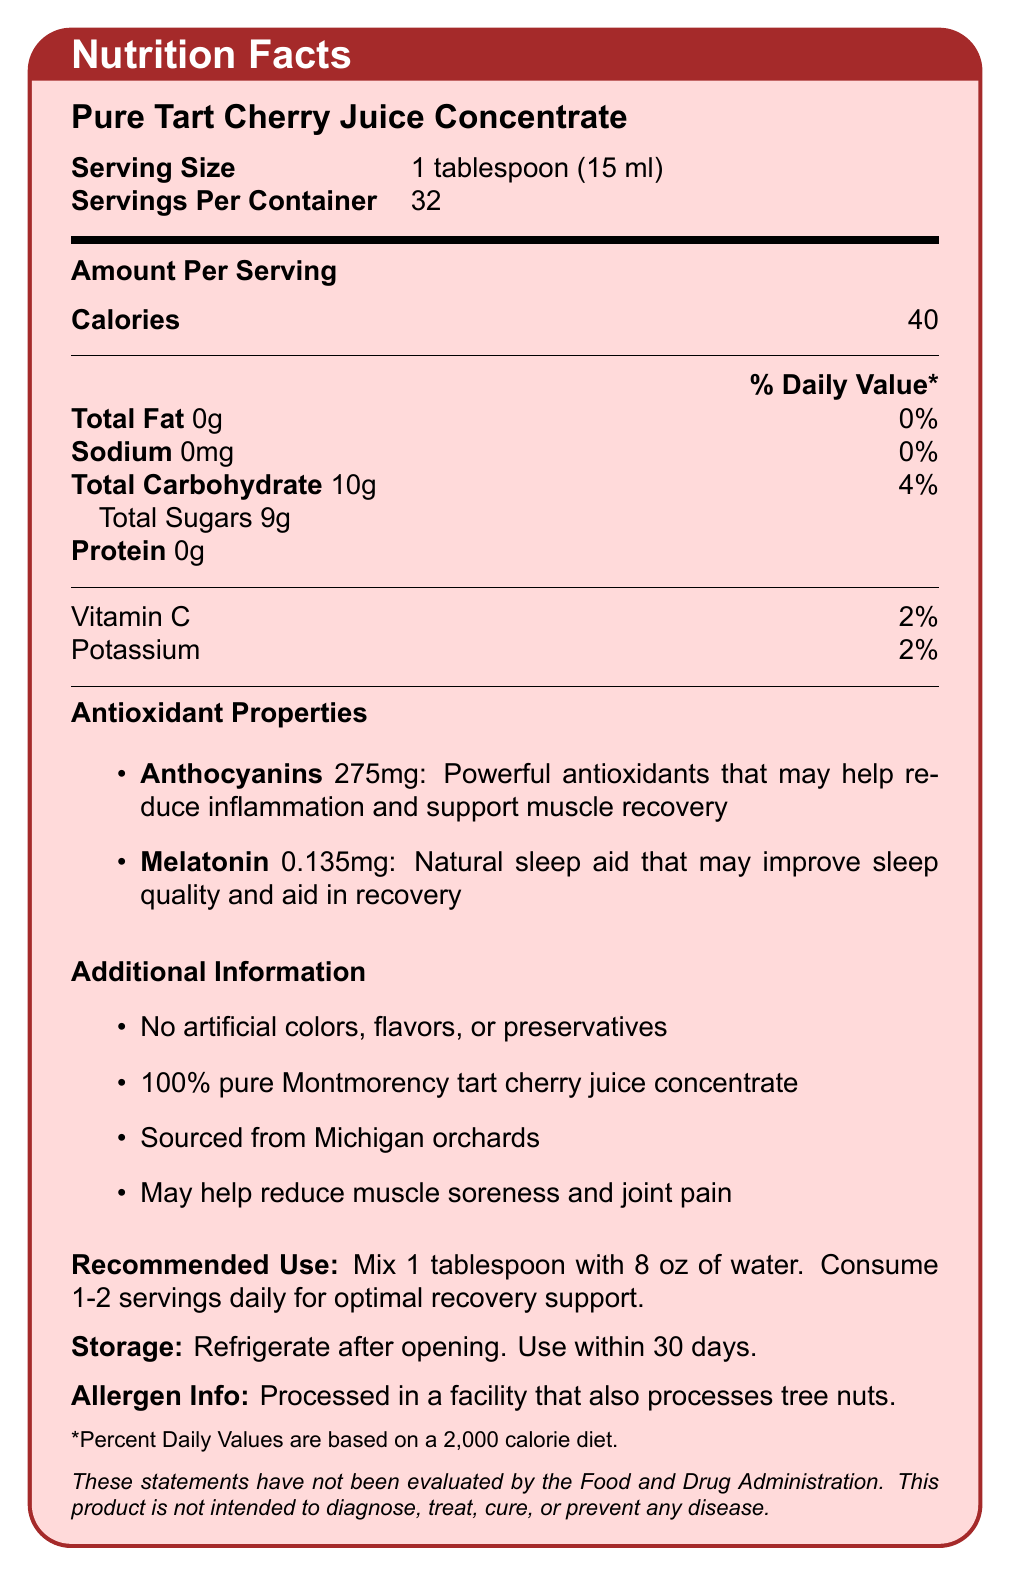what is the serving size? The document states the serving size clearly as "1 tablespoon (15 ml)".
Answer: 1 tablespoon (15 ml) how many calories are in one serving of tart cherry juice concentrate? The document lists "Calories" as 40 per serving.
Answer: 40 what is the amount of total fat per serving? Under the nutrition facts, "Total Fat" per serving is listed as 0g.
Answer: 0g what is the daily value percentage for total carbohydrates? The document indicates that total carbohydrate daily value is 4%.
Answer: 4% what is the main purpose of anthocyanins found in the tart cherry juice concentrate? The document explains that anthocyanins are powerful antioxidants that may help reduce inflammation and support muscle recovery.
Answer: Help reduce inflammation and support muscle recovery how much potassium does one serving contain? A. 50mg B. 75mg C. 100mg D. 150mg The document specifies that one serving contains 100mg of potassium.
Answer: C. 100mg which statement is true about melatonin in the tart cherry juice concentrate? A. Melatonin amount is 0.5mg B. Melatonin is a natural sleep aid C. Melatonin helps improve energy levels D. Melatonin reduces sodium levels The document describes melatonin as a natural sleep aid that may improve sleep quality and aid in recovery.
Answer: B. Melatonin is a natural sleep aid does the tart cherry juice concentrate contain any protein? The document lists protein content as 0g per serving.
Answer: No is this product free of artificial colors, flavors, and preservatives? The document mentions "No artificial colors, flavors, or preservatives".
Answer: Yes summarize the main benefits of this tart cherry juice concentrate for someone recovering from a sports injury. The benefits section highlights that the product's natural anti-inflammatory properties may aid in sports injury recovery, reduce muscle soreness and joint pain, and support overall recovery and sleep quality.
Answer: The tart cherry juice concentrate provides natural anti-inflammatory properties, helps reduce muscle soreness and joint pain, supports overall recovery and sleep quality, and does so without any artificial additives. can this tart cherry juice concentrate be used to treat or cure diseases? The disclaimer in the document states that this product is not intended to diagnose, treat, cure, or prevent any disease.
Answer: No what is the daily value percentage of vitamin C per serving? The document lists Vitamin C's daily value per serving as 2%.
Answer: 2% how often should one consume this product for optimal recovery support? A. Once weekly B. 1-2 servings daily C. 3 times a week D. Only when needed The recommended use section advises consuming 1-2 servings daily for optimal recovery support.
Answer: B. 1-2 servings daily after opening, how long can the tart cherry juice concentrate be used? The storage information indicates to use the product within 30 days after opening.
Answer: 30 days where is the tart cherry juice concentrate sourced from? The additional information section states that it is sourced from Michigan orchards.
Answer: Michigan orchards is the tart cherry juice concentrate processed in a facility that handles tree nuts? The allergen info specifies that it is processed in a facility that also processes tree nuts.
Answer: Yes does the document provide information on the exact orchard location? The document mentions Michigan orchards but doesn't specify the exact location.
Answer: Cannot be determined what are some of the additional information points mentioned about the tart cherry juice concentrate? The additional information section lists these points clearly related to the product.
Answer: No artificial colors, flavors, or preservatives; 100% pure Montmorency tart cherry juice concentrate; sourced from Michigan orchards; may help reduce muscle soreness and joint pain. what type of antioxidants does the tart cherry juice concentrate contain? The antioxidant properties section mentions anthocyanins specifically.
Answer: Anthocyanins what is the amount of total sugars in one serving? The document lists the total sugars content as 9g per serving.
Answer: 9g 